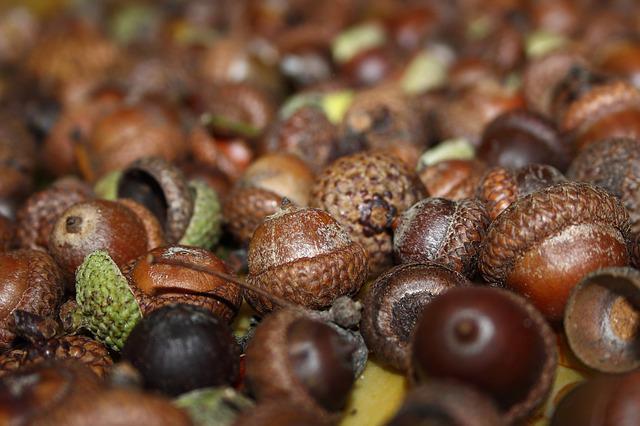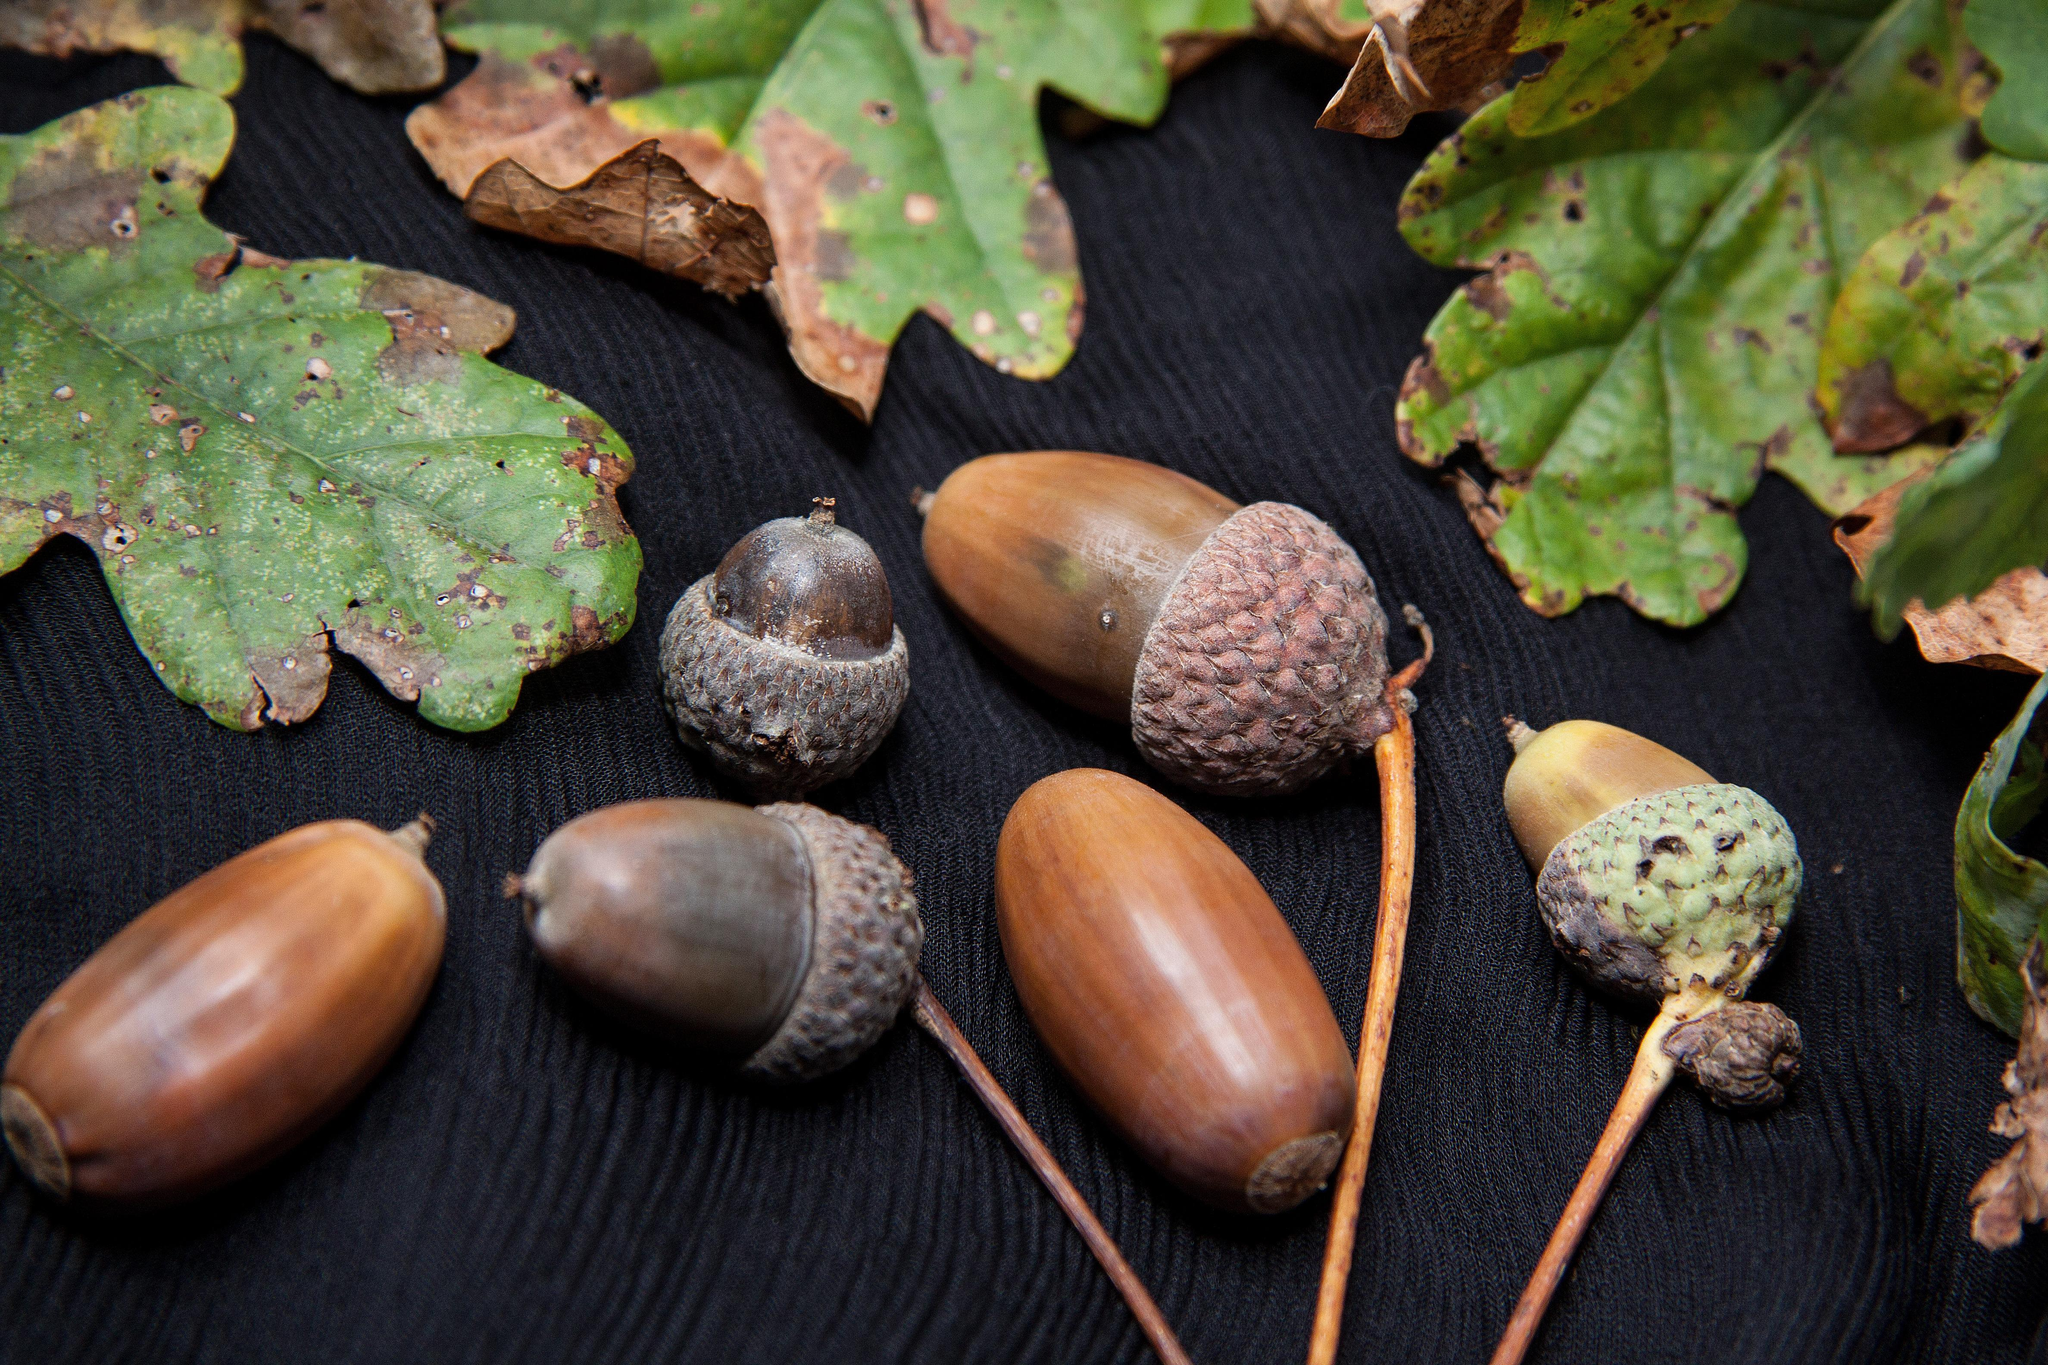The first image is the image on the left, the second image is the image on the right. Considering the images on both sides, is "The left image includes at least one large green acorn with its cap on next to smaller brown acorns." valid? Answer yes or no. No. 